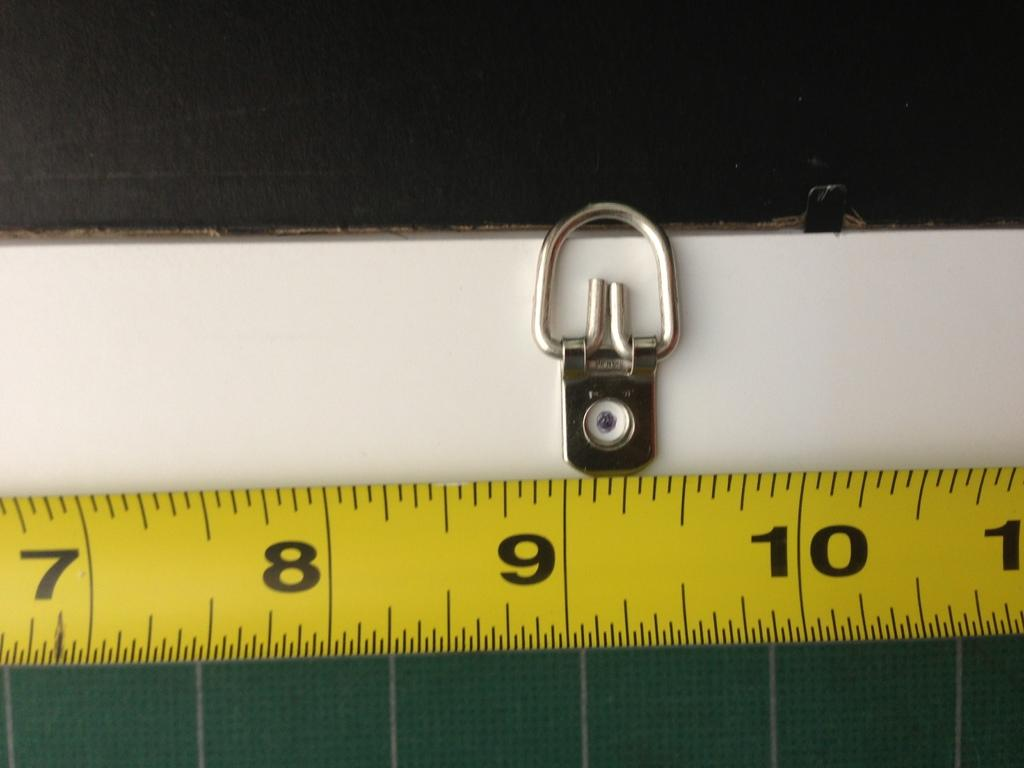Provide a one-sentence caption for the provided image. a measuring tape with #'s (in inches) 7, 8, 9 and 10 visible. 